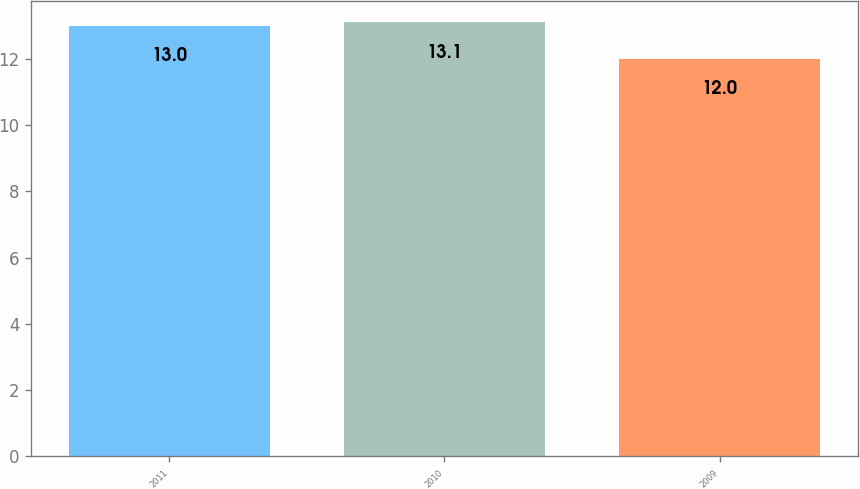<chart> <loc_0><loc_0><loc_500><loc_500><bar_chart><fcel>2011<fcel>2010<fcel>2009<nl><fcel>13<fcel>13.1<fcel>12<nl></chart> 